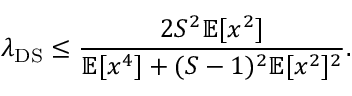<formula> <loc_0><loc_0><loc_500><loc_500>\lambda _ { D S } \leq \frac { 2 S ^ { 2 } \mathbb { E } [ x ^ { 2 } ] } { \mathbb { E } [ x ^ { 4 } ] + ( S - 1 ) ^ { 2 } \mathbb { E } [ x ^ { 2 } ] ^ { 2 } } .</formula> 